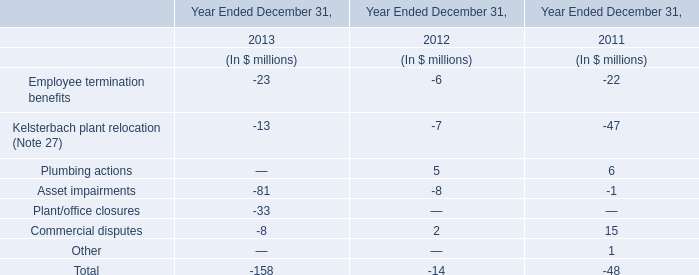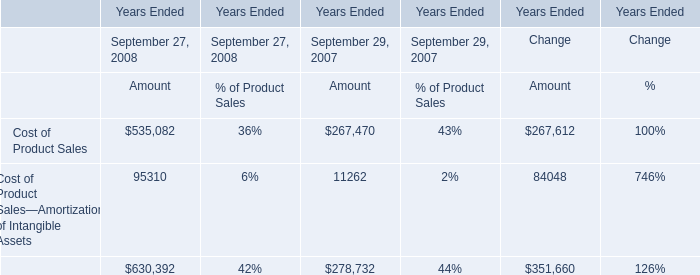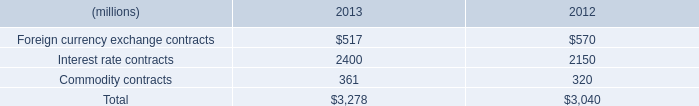what was the percentage change in the company recognized tax-related interest and penalties in 2011 . 
Computations: (3 / (16 + 3))
Answer: 0.15789. what's the total amount of Cost of Product Sales of Years Ended Change Amount, Interest rate contracts of 2012, and Cost of Product Sales—Amortization of Intangible Assets of Years Ended Change Amount ? 
Computations: ((267612.0 + 2150.0) + 84048.0)
Answer: 353810.0. 